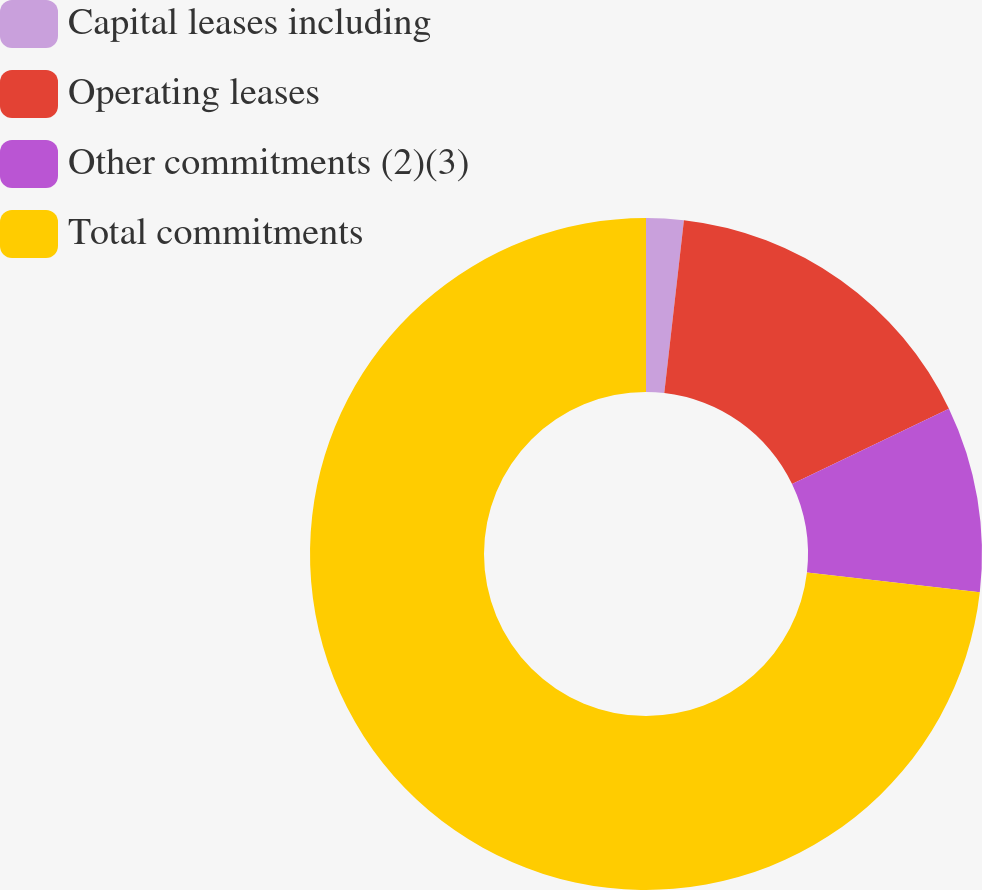<chart> <loc_0><loc_0><loc_500><loc_500><pie_chart><fcel>Capital leases including<fcel>Operating leases<fcel>Other commitments (2)(3)<fcel>Total commitments<nl><fcel>1.8%<fcel>16.08%<fcel>8.94%<fcel>73.18%<nl></chart> 